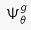<formula> <loc_0><loc_0><loc_500><loc_500>\Psi _ { \theta } ^ { g }</formula> 